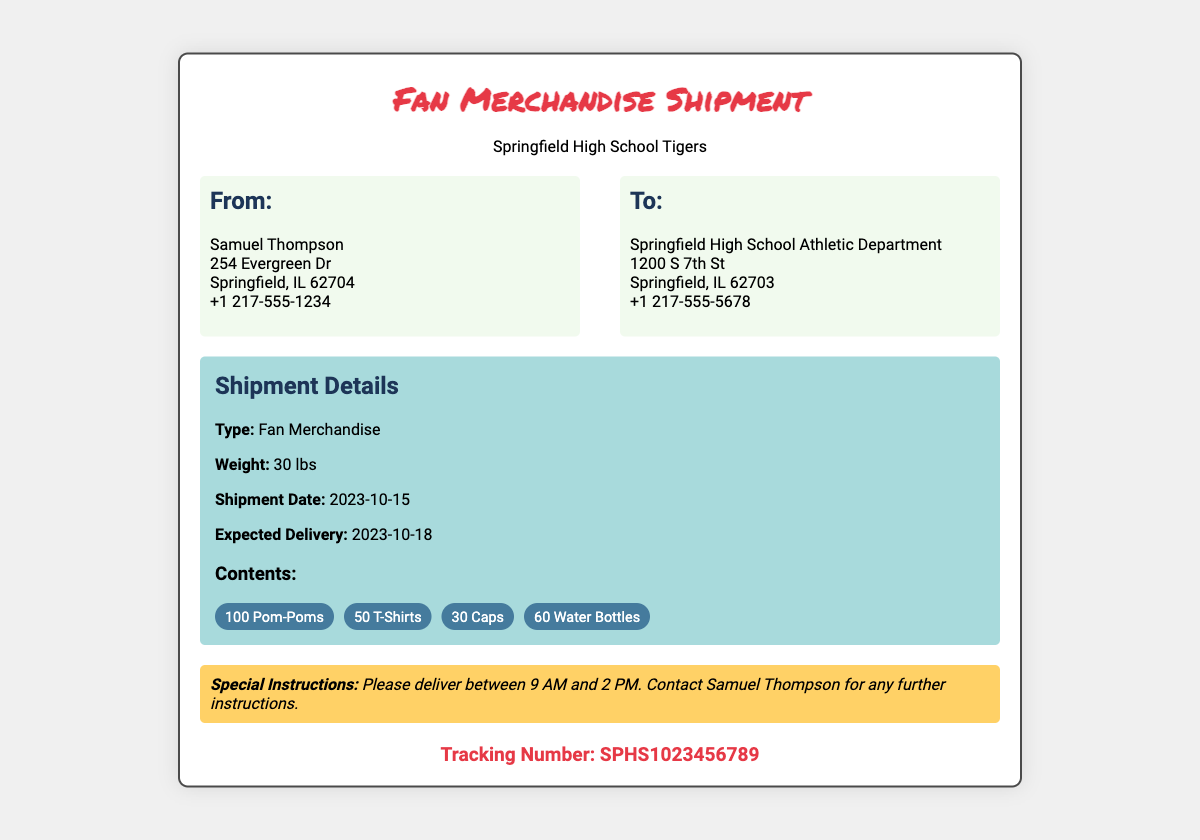What is the shipment date? The shipment date is specified under shipment details.
Answer: 2023-10-15 Who is the sender? The sender's name is listed at the top of the "From" address section.
Answer: Samuel Thompson How many T-shirts are included in the shipment? The number of T-shirts is mentioned in the contents section of the label.
Answer: 50 What is the expected delivery date? The expected delivery date is indicated in the shipment details.
Answer: 2023-10-18 What is the tracking number? The tracking number is listed at the bottom of the document.
Answer: SPHS1023456789 Where is the shipment being sent to? The recipient's address is found in the "To" section of the label.
Answer: Springfield High School Athletic Department What is the total weight of the shipment? The total weight is specified in the shipment details.
Answer: 30 lbs When should the package be delivered? The delivery time is noted in the special instructions section.
Answer: Between 9 AM and 2 PM How many pom-poms are included? The quantity of pom-poms is listed under the contents section.
Answer: 100 